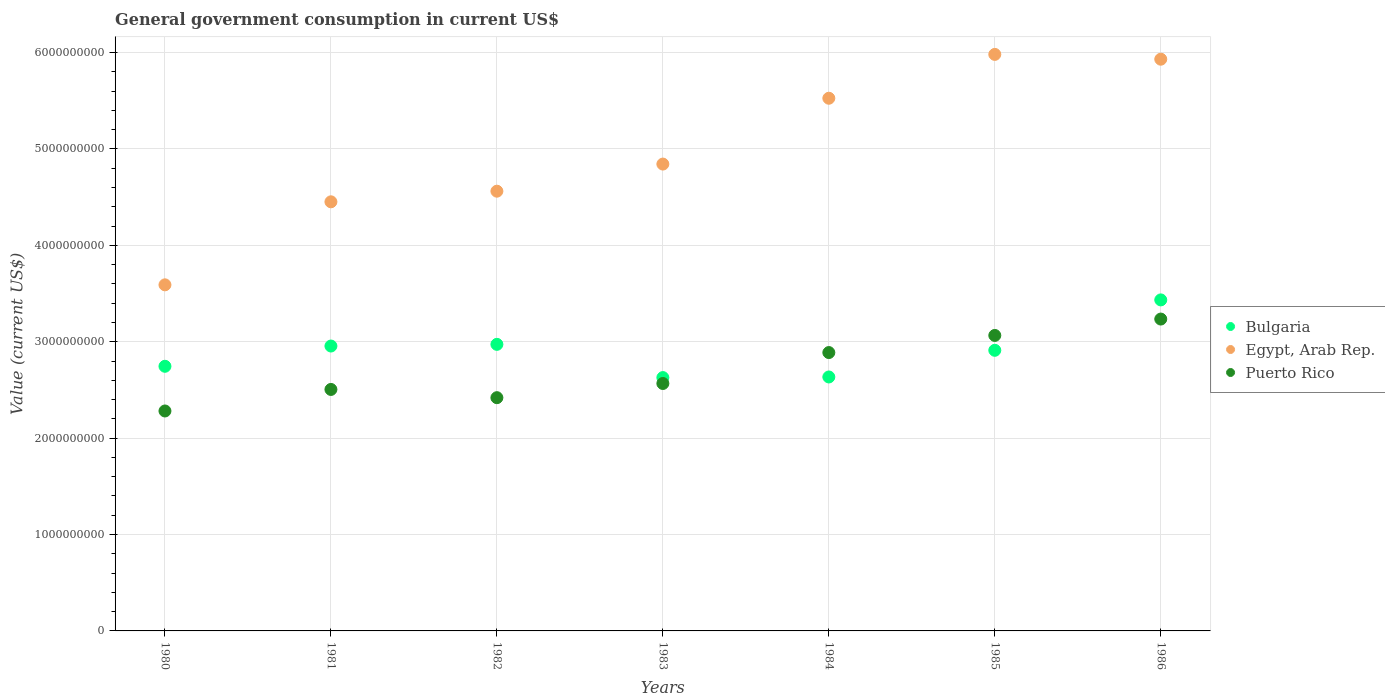How many different coloured dotlines are there?
Offer a very short reply. 3. Is the number of dotlines equal to the number of legend labels?
Your response must be concise. Yes. What is the government conusmption in Bulgaria in 1985?
Offer a terse response. 2.91e+09. Across all years, what is the maximum government conusmption in Egypt, Arab Rep.?
Keep it short and to the point. 5.98e+09. Across all years, what is the minimum government conusmption in Bulgaria?
Offer a very short reply. 2.63e+09. What is the total government conusmption in Bulgaria in the graph?
Provide a short and direct response. 2.03e+1. What is the difference between the government conusmption in Bulgaria in 1981 and that in 1983?
Give a very brief answer. 3.27e+08. What is the difference between the government conusmption in Bulgaria in 1984 and the government conusmption in Egypt, Arab Rep. in 1986?
Offer a very short reply. -3.30e+09. What is the average government conusmption in Puerto Rico per year?
Provide a short and direct response. 2.71e+09. In the year 1984, what is the difference between the government conusmption in Bulgaria and government conusmption in Puerto Rico?
Your answer should be compact. -2.53e+08. What is the ratio of the government conusmption in Bulgaria in 1981 to that in 1983?
Your response must be concise. 1.12. What is the difference between the highest and the second highest government conusmption in Puerto Rico?
Your answer should be very brief. 1.70e+08. What is the difference between the highest and the lowest government conusmption in Puerto Rico?
Offer a terse response. 9.54e+08. In how many years, is the government conusmption in Bulgaria greater than the average government conusmption in Bulgaria taken over all years?
Your answer should be compact. 4. Is the sum of the government conusmption in Bulgaria in 1980 and 1981 greater than the maximum government conusmption in Puerto Rico across all years?
Your answer should be very brief. Yes. Is it the case that in every year, the sum of the government conusmption in Bulgaria and government conusmption in Puerto Rico  is greater than the government conusmption in Egypt, Arab Rep.?
Keep it short and to the point. No. Does the government conusmption in Puerto Rico monotonically increase over the years?
Offer a terse response. No. Is the government conusmption in Bulgaria strictly greater than the government conusmption in Egypt, Arab Rep. over the years?
Provide a short and direct response. No. Is the government conusmption in Puerto Rico strictly less than the government conusmption in Egypt, Arab Rep. over the years?
Provide a succinct answer. Yes. How many dotlines are there?
Give a very brief answer. 3. What is the difference between two consecutive major ticks on the Y-axis?
Your answer should be compact. 1.00e+09. Does the graph contain any zero values?
Offer a very short reply. No. Does the graph contain grids?
Offer a very short reply. Yes. How many legend labels are there?
Ensure brevity in your answer.  3. What is the title of the graph?
Your answer should be compact. General government consumption in current US$. Does "Jordan" appear as one of the legend labels in the graph?
Keep it short and to the point. No. What is the label or title of the Y-axis?
Your answer should be compact. Value (current US$). What is the Value (current US$) of Bulgaria in 1980?
Make the answer very short. 2.75e+09. What is the Value (current US$) of Egypt, Arab Rep. in 1980?
Ensure brevity in your answer.  3.59e+09. What is the Value (current US$) in Puerto Rico in 1980?
Ensure brevity in your answer.  2.28e+09. What is the Value (current US$) of Bulgaria in 1981?
Offer a very short reply. 2.96e+09. What is the Value (current US$) in Egypt, Arab Rep. in 1981?
Offer a very short reply. 4.45e+09. What is the Value (current US$) in Puerto Rico in 1981?
Offer a very short reply. 2.50e+09. What is the Value (current US$) of Bulgaria in 1982?
Provide a short and direct response. 2.97e+09. What is the Value (current US$) in Egypt, Arab Rep. in 1982?
Ensure brevity in your answer.  4.56e+09. What is the Value (current US$) of Puerto Rico in 1982?
Keep it short and to the point. 2.42e+09. What is the Value (current US$) of Bulgaria in 1983?
Your answer should be very brief. 2.63e+09. What is the Value (current US$) in Egypt, Arab Rep. in 1983?
Make the answer very short. 4.84e+09. What is the Value (current US$) in Puerto Rico in 1983?
Offer a terse response. 2.57e+09. What is the Value (current US$) of Bulgaria in 1984?
Ensure brevity in your answer.  2.63e+09. What is the Value (current US$) of Egypt, Arab Rep. in 1984?
Keep it short and to the point. 5.53e+09. What is the Value (current US$) in Puerto Rico in 1984?
Offer a very short reply. 2.89e+09. What is the Value (current US$) in Bulgaria in 1985?
Provide a short and direct response. 2.91e+09. What is the Value (current US$) in Egypt, Arab Rep. in 1985?
Your answer should be very brief. 5.98e+09. What is the Value (current US$) of Puerto Rico in 1985?
Your response must be concise. 3.07e+09. What is the Value (current US$) of Bulgaria in 1986?
Provide a succinct answer. 3.43e+09. What is the Value (current US$) of Egypt, Arab Rep. in 1986?
Offer a terse response. 5.93e+09. What is the Value (current US$) in Puerto Rico in 1986?
Your answer should be very brief. 3.24e+09. Across all years, what is the maximum Value (current US$) of Bulgaria?
Provide a succinct answer. 3.43e+09. Across all years, what is the maximum Value (current US$) in Egypt, Arab Rep.?
Provide a short and direct response. 5.98e+09. Across all years, what is the maximum Value (current US$) of Puerto Rico?
Offer a terse response. 3.24e+09. Across all years, what is the minimum Value (current US$) of Bulgaria?
Provide a succinct answer. 2.63e+09. Across all years, what is the minimum Value (current US$) of Egypt, Arab Rep.?
Make the answer very short. 3.59e+09. Across all years, what is the minimum Value (current US$) in Puerto Rico?
Keep it short and to the point. 2.28e+09. What is the total Value (current US$) of Bulgaria in the graph?
Your answer should be very brief. 2.03e+1. What is the total Value (current US$) of Egypt, Arab Rep. in the graph?
Keep it short and to the point. 3.49e+1. What is the total Value (current US$) of Puerto Rico in the graph?
Make the answer very short. 1.90e+1. What is the difference between the Value (current US$) of Bulgaria in 1980 and that in 1981?
Offer a terse response. -2.10e+08. What is the difference between the Value (current US$) in Egypt, Arab Rep. in 1980 and that in 1981?
Offer a terse response. -8.61e+08. What is the difference between the Value (current US$) of Puerto Rico in 1980 and that in 1981?
Your response must be concise. -2.23e+08. What is the difference between the Value (current US$) in Bulgaria in 1980 and that in 1982?
Keep it short and to the point. -2.28e+08. What is the difference between the Value (current US$) in Egypt, Arab Rep. in 1980 and that in 1982?
Offer a very short reply. -9.71e+08. What is the difference between the Value (current US$) of Puerto Rico in 1980 and that in 1982?
Offer a very short reply. -1.38e+08. What is the difference between the Value (current US$) of Bulgaria in 1980 and that in 1983?
Offer a terse response. 1.17e+08. What is the difference between the Value (current US$) of Egypt, Arab Rep. in 1980 and that in 1983?
Provide a succinct answer. -1.25e+09. What is the difference between the Value (current US$) of Puerto Rico in 1980 and that in 1983?
Make the answer very short. -2.85e+08. What is the difference between the Value (current US$) in Bulgaria in 1980 and that in 1984?
Provide a succinct answer. 1.11e+08. What is the difference between the Value (current US$) of Egypt, Arab Rep. in 1980 and that in 1984?
Provide a succinct answer. -1.94e+09. What is the difference between the Value (current US$) of Puerto Rico in 1980 and that in 1984?
Keep it short and to the point. -6.06e+08. What is the difference between the Value (current US$) in Bulgaria in 1980 and that in 1985?
Give a very brief answer. -1.66e+08. What is the difference between the Value (current US$) of Egypt, Arab Rep. in 1980 and that in 1985?
Offer a very short reply. -2.39e+09. What is the difference between the Value (current US$) in Puerto Rico in 1980 and that in 1985?
Your answer should be very brief. -7.84e+08. What is the difference between the Value (current US$) of Bulgaria in 1980 and that in 1986?
Your answer should be very brief. -6.89e+08. What is the difference between the Value (current US$) of Egypt, Arab Rep. in 1980 and that in 1986?
Ensure brevity in your answer.  -2.34e+09. What is the difference between the Value (current US$) of Puerto Rico in 1980 and that in 1986?
Offer a terse response. -9.54e+08. What is the difference between the Value (current US$) of Bulgaria in 1981 and that in 1982?
Give a very brief answer. -1.74e+07. What is the difference between the Value (current US$) in Egypt, Arab Rep. in 1981 and that in 1982?
Offer a terse response. -1.10e+08. What is the difference between the Value (current US$) of Puerto Rico in 1981 and that in 1982?
Give a very brief answer. 8.54e+07. What is the difference between the Value (current US$) of Bulgaria in 1981 and that in 1983?
Offer a very short reply. 3.27e+08. What is the difference between the Value (current US$) of Egypt, Arab Rep. in 1981 and that in 1983?
Offer a very short reply. -3.91e+08. What is the difference between the Value (current US$) in Puerto Rico in 1981 and that in 1983?
Offer a very short reply. -6.17e+07. What is the difference between the Value (current US$) in Bulgaria in 1981 and that in 1984?
Provide a succinct answer. 3.21e+08. What is the difference between the Value (current US$) of Egypt, Arab Rep. in 1981 and that in 1984?
Offer a terse response. -1.07e+09. What is the difference between the Value (current US$) in Puerto Rico in 1981 and that in 1984?
Your answer should be very brief. -3.83e+08. What is the difference between the Value (current US$) of Bulgaria in 1981 and that in 1985?
Your response must be concise. 4.43e+07. What is the difference between the Value (current US$) in Egypt, Arab Rep. in 1981 and that in 1985?
Offer a terse response. -1.53e+09. What is the difference between the Value (current US$) of Puerto Rico in 1981 and that in 1985?
Provide a short and direct response. -5.60e+08. What is the difference between the Value (current US$) of Bulgaria in 1981 and that in 1986?
Your answer should be compact. -4.79e+08. What is the difference between the Value (current US$) of Egypt, Arab Rep. in 1981 and that in 1986?
Ensure brevity in your answer.  -1.48e+09. What is the difference between the Value (current US$) of Puerto Rico in 1981 and that in 1986?
Give a very brief answer. -7.30e+08. What is the difference between the Value (current US$) in Bulgaria in 1982 and that in 1983?
Provide a succinct answer. 3.45e+08. What is the difference between the Value (current US$) of Egypt, Arab Rep. in 1982 and that in 1983?
Provide a short and direct response. -2.81e+08. What is the difference between the Value (current US$) in Puerto Rico in 1982 and that in 1983?
Provide a succinct answer. -1.47e+08. What is the difference between the Value (current US$) in Bulgaria in 1982 and that in 1984?
Give a very brief answer. 3.38e+08. What is the difference between the Value (current US$) in Egypt, Arab Rep. in 1982 and that in 1984?
Your response must be concise. -9.64e+08. What is the difference between the Value (current US$) of Puerto Rico in 1982 and that in 1984?
Keep it short and to the point. -4.68e+08. What is the difference between the Value (current US$) in Bulgaria in 1982 and that in 1985?
Make the answer very short. 6.17e+07. What is the difference between the Value (current US$) in Egypt, Arab Rep. in 1982 and that in 1985?
Give a very brief answer. -1.42e+09. What is the difference between the Value (current US$) of Puerto Rico in 1982 and that in 1985?
Provide a succinct answer. -6.46e+08. What is the difference between the Value (current US$) in Bulgaria in 1982 and that in 1986?
Your response must be concise. -4.61e+08. What is the difference between the Value (current US$) in Egypt, Arab Rep. in 1982 and that in 1986?
Your answer should be very brief. -1.37e+09. What is the difference between the Value (current US$) of Puerto Rico in 1982 and that in 1986?
Make the answer very short. -8.16e+08. What is the difference between the Value (current US$) in Bulgaria in 1983 and that in 1984?
Ensure brevity in your answer.  -6.32e+06. What is the difference between the Value (current US$) in Egypt, Arab Rep. in 1983 and that in 1984?
Provide a short and direct response. -6.83e+08. What is the difference between the Value (current US$) in Puerto Rico in 1983 and that in 1984?
Offer a terse response. -3.21e+08. What is the difference between the Value (current US$) in Bulgaria in 1983 and that in 1985?
Make the answer very short. -2.83e+08. What is the difference between the Value (current US$) of Egypt, Arab Rep. in 1983 and that in 1985?
Make the answer very short. -1.14e+09. What is the difference between the Value (current US$) in Puerto Rico in 1983 and that in 1985?
Ensure brevity in your answer.  -4.98e+08. What is the difference between the Value (current US$) in Bulgaria in 1983 and that in 1986?
Ensure brevity in your answer.  -8.06e+08. What is the difference between the Value (current US$) in Egypt, Arab Rep. in 1983 and that in 1986?
Offer a very short reply. -1.09e+09. What is the difference between the Value (current US$) of Puerto Rico in 1983 and that in 1986?
Make the answer very short. -6.68e+08. What is the difference between the Value (current US$) of Bulgaria in 1984 and that in 1985?
Your answer should be very brief. -2.77e+08. What is the difference between the Value (current US$) in Egypt, Arab Rep. in 1984 and that in 1985?
Give a very brief answer. -4.55e+08. What is the difference between the Value (current US$) in Puerto Rico in 1984 and that in 1985?
Provide a succinct answer. -1.78e+08. What is the difference between the Value (current US$) in Bulgaria in 1984 and that in 1986?
Offer a terse response. -7.99e+08. What is the difference between the Value (current US$) of Egypt, Arab Rep. in 1984 and that in 1986?
Your response must be concise. -4.05e+08. What is the difference between the Value (current US$) of Puerto Rico in 1984 and that in 1986?
Make the answer very short. -3.48e+08. What is the difference between the Value (current US$) in Bulgaria in 1985 and that in 1986?
Give a very brief answer. -5.23e+08. What is the difference between the Value (current US$) in Egypt, Arab Rep. in 1985 and that in 1986?
Make the answer very short. 4.97e+07. What is the difference between the Value (current US$) of Puerto Rico in 1985 and that in 1986?
Offer a terse response. -1.70e+08. What is the difference between the Value (current US$) in Bulgaria in 1980 and the Value (current US$) in Egypt, Arab Rep. in 1981?
Ensure brevity in your answer.  -1.71e+09. What is the difference between the Value (current US$) in Bulgaria in 1980 and the Value (current US$) in Puerto Rico in 1981?
Ensure brevity in your answer.  2.40e+08. What is the difference between the Value (current US$) in Egypt, Arab Rep. in 1980 and the Value (current US$) in Puerto Rico in 1981?
Provide a succinct answer. 1.09e+09. What is the difference between the Value (current US$) in Bulgaria in 1980 and the Value (current US$) in Egypt, Arab Rep. in 1982?
Your answer should be very brief. -1.82e+09. What is the difference between the Value (current US$) in Bulgaria in 1980 and the Value (current US$) in Puerto Rico in 1982?
Keep it short and to the point. 3.26e+08. What is the difference between the Value (current US$) of Egypt, Arab Rep. in 1980 and the Value (current US$) of Puerto Rico in 1982?
Make the answer very short. 1.17e+09. What is the difference between the Value (current US$) of Bulgaria in 1980 and the Value (current US$) of Egypt, Arab Rep. in 1983?
Your response must be concise. -2.10e+09. What is the difference between the Value (current US$) of Bulgaria in 1980 and the Value (current US$) of Puerto Rico in 1983?
Make the answer very short. 1.78e+08. What is the difference between the Value (current US$) of Egypt, Arab Rep. in 1980 and the Value (current US$) of Puerto Rico in 1983?
Keep it short and to the point. 1.02e+09. What is the difference between the Value (current US$) in Bulgaria in 1980 and the Value (current US$) in Egypt, Arab Rep. in 1984?
Offer a terse response. -2.78e+09. What is the difference between the Value (current US$) of Bulgaria in 1980 and the Value (current US$) of Puerto Rico in 1984?
Your answer should be very brief. -1.42e+08. What is the difference between the Value (current US$) of Egypt, Arab Rep. in 1980 and the Value (current US$) of Puerto Rico in 1984?
Make the answer very short. 7.03e+08. What is the difference between the Value (current US$) in Bulgaria in 1980 and the Value (current US$) in Egypt, Arab Rep. in 1985?
Make the answer very short. -3.24e+09. What is the difference between the Value (current US$) in Bulgaria in 1980 and the Value (current US$) in Puerto Rico in 1985?
Offer a terse response. -3.20e+08. What is the difference between the Value (current US$) of Egypt, Arab Rep. in 1980 and the Value (current US$) of Puerto Rico in 1985?
Offer a very short reply. 5.25e+08. What is the difference between the Value (current US$) in Bulgaria in 1980 and the Value (current US$) in Egypt, Arab Rep. in 1986?
Your response must be concise. -3.19e+09. What is the difference between the Value (current US$) in Bulgaria in 1980 and the Value (current US$) in Puerto Rico in 1986?
Your answer should be very brief. -4.90e+08. What is the difference between the Value (current US$) of Egypt, Arab Rep. in 1980 and the Value (current US$) of Puerto Rico in 1986?
Provide a succinct answer. 3.55e+08. What is the difference between the Value (current US$) in Bulgaria in 1981 and the Value (current US$) in Egypt, Arab Rep. in 1982?
Give a very brief answer. -1.61e+09. What is the difference between the Value (current US$) of Bulgaria in 1981 and the Value (current US$) of Puerto Rico in 1982?
Provide a succinct answer. 5.36e+08. What is the difference between the Value (current US$) of Egypt, Arab Rep. in 1981 and the Value (current US$) of Puerto Rico in 1982?
Ensure brevity in your answer.  2.03e+09. What is the difference between the Value (current US$) of Bulgaria in 1981 and the Value (current US$) of Egypt, Arab Rep. in 1983?
Keep it short and to the point. -1.89e+09. What is the difference between the Value (current US$) of Bulgaria in 1981 and the Value (current US$) of Puerto Rico in 1983?
Offer a terse response. 3.89e+08. What is the difference between the Value (current US$) of Egypt, Arab Rep. in 1981 and the Value (current US$) of Puerto Rico in 1983?
Ensure brevity in your answer.  1.88e+09. What is the difference between the Value (current US$) in Bulgaria in 1981 and the Value (current US$) in Egypt, Arab Rep. in 1984?
Offer a terse response. -2.57e+09. What is the difference between the Value (current US$) of Bulgaria in 1981 and the Value (current US$) of Puerto Rico in 1984?
Offer a very short reply. 6.77e+07. What is the difference between the Value (current US$) in Egypt, Arab Rep. in 1981 and the Value (current US$) in Puerto Rico in 1984?
Your answer should be very brief. 1.56e+09. What is the difference between the Value (current US$) in Bulgaria in 1981 and the Value (current US$) in Egypt, Arab Rep. in 1985?
Your answer should be very brief. -3.03e+09. What is the difference between the Value (current US$) in Bulgaria in 1981 and the Value (current US$) in Puerto Rico in 1985?
Your response must be concise. -1.10e+08. What is the difference between the Value (current US$) of Egypt, Arab Rep. in 1981 and the Value (current US$) of Puerto Rico in 1985?
Offer a terse response. 1.39e+09. What is the difference between the Value (current US$) in Bulgaria in 1981 and the Value (current US$) in Egypt, Arab Rep. in 1986?
Give a very brief answer. -2.98e+09. What is the difference between the Value (current US$) of Bulgaria in 1981 and the Value (current US$) of Puerto Rico in 1986?
Your answer should be compact. -2.80e+08. What is the difference between the Value (current US$) in Egypt, Arab Rep. in 1981 and the Value (current US$) in Puerto Rico in 1986?
Your answer should be compact. 1.22e+09. What is the difference between the Value (current US$) in Bulgaria in 1982 and the Value (current US$) in Egypt, Arab Rep. in 1983?
Keep it short and to the point. -1.87e+09. What is the difference between the Value (current US$) in Bulgaria in 1982 and the Value (current US$) in Puerto Rico in 1983?
Provide a short and direct response. 4.06e+08. What is the difference between the Value (current US$) in Egypt, Arab Rep. in 1982 and the Value (current US$) in Puerto Rico in 1983?
Make the answer very short. 1.99e+09. What is the difference between the Value (current US$) of Bulgaria in 1982 and the Value (current US$) of Egypt, Arab Rep. in 1984?
Make the answer very short. -2.55e+09. What is the difference between the Value (current US$) in Bulgaria in 1982 and the Value (current US$) in Puerto Rico in 1984?
Provide a succinct answer. 8.51e+07. What is the difference between the Value (current US$) in Egypt, Arab Rep. in 1982 and the Value (current US$) in Puerto Rico in 1984?
Ensure brevity in your answer.  1.67e+09. What is the difference between the Value (current US$) in Bulgaria in 1982 and the Value (current US$) in Egypt, Arab Rep. in 1985?
Offer a very short reply. -3.01e+09. What is the difference between the Value (current US$) in Bulgaria in 1982 and the Value (current US$) in Puerto Rico in 1985?
Give a very brief answer. -9.25e+07. What is the difference between the Value (current US$) in Egypt, Arab Rep. in 1982 and the Value (current US$) in Puerto Rico in 1985?
Your answer should be compact. 1.50e+09. What is the difference between the Value (current US$) in Bulgaria in 1982 and the Value (current US$) in Egypt, Arab Rep. in 1986?
Offer a terse response. -2.96e+09. What is the difference between the Value (current US$) of Bulgaria in 1982 and the Value (current US$) of Puerto Rico in 1986?
Give a very brief answer. -2.62e+08. What is the difference between the Value (current US$) in Egypt, Arab Rep. in 1982 and the Value (current US$) in Puerto Rico in 1986?
Keep it short and to the point. 1.33e+09. What is the difference between the Value (current US$) of Bulgaria in 1983 and the Value (current US$) of Egypt, Arab Rep. in 1984?
Ensure brevity in your answer.  -2.90e+09. What is the difference between the Value (current US$) in Bulgaria in 1983 and the Value (current US$) in Puerto Rico in 1984?
Give a very brief answer. -2.60e+08. What is the difference between the Value (current US$) in Egypt, Arab Rep. in 1983 and the Value (current US$) in Puerto Rico in 1984?
Your answer should be very brief. 1.96e+09. What is the difference between the Value (current US$) in Bulgaria in 1983 and the Value (current US$) in Egypt, Arab Rep. in 1985?
Make the answer very short. -3.35e+09. What is the difference between the Value (current US$) in Bulgaria in 1983 and the Value (current US$) in Puerto Rico in 1985?
Make the answer very short. -4.37e+08. What is the difference between the Value (current US$) of Egypt, Arab Rep. in 1983 and the Value (current US$) of Puerto Rico in 1985?
Your answer should be compact. 1.78e+09. What is the difference between the Value (current US$) of Bulgaria in 1983 and the Value (current US$) of Egypt, Arab Rep. in 1986?
Give a very brief answer. -3.30e+09. What is the difference between the Value (current US$) of Bulgaria in 1983 and the Value (current US$) of Puerto Rico in 1986?
Keep it short and to the point. -6.07e+08. What is the difference between the Value (current US$) of Egypt, Arab Rep. in 1983 and the Value (current US$) of Puerto Rico in 1986?
Your answer should be compact. 1.61e+09. What is the difference between the Value (current US$) of Bulgaria in 1984 and the Value (current US$) of Egypt, Arab Rep. in 1985?
Your answer should be very brief. -3.35e+09. What is the difference between the Value (current US$) in Bulgaria in 1984 and the Value (current US$) in Puerto Rico in 1985?
Offer a very short reply. -4.31e+08. What is the difference between the Value (current US$) in Egypt, Arab Rep. in 1984 and the Value (current US$) in Puerto Rico in 1985?
Ensure brevity in your answer.  2.46e+09. What is the difference between the Value (current US$) of Bulgaria in 1984 and the Value (current US$) of Egypt, Arab Rep. in 1986?
Offer a terse response. -3.30e+09. What is the difference between the Value (current US$) in Bulgaria in 1984 and the Value (current US$) in Puerto Rico in 1986?
Keep it short and to the point. -6.01e+08. What is the difference between the Value (current US$) of Egypt, Arab Rep. in 1984 and the Value (current US$) of Puerto Rico in 1986?
Provide a short and direct response. 2.29e+09. What is the difference between the Value (current US$) of Bulgaria in 1985 and the Value (current US$) of Egypt, Arab Rep. in 1986?
Ensure brevity in your answer.  -3.02e+09. What is the difference between the Value (current US$) of Bulgaria in 1985 and the Value (current US$) of Puerto Rico in 1986?
Give a very brief answer. -3.24e+08. What is the difference between the Value (current US$) in Egypt, Arab Rep. in 1985 and the Value (current US$) in Puerto Rico in 1986?
Provide a short and direct response. 2.75e+09. What is the average Value (current US$) of Bulgaria per year?
Keep it short and to the point. 2.90e+09. What is the average Value (current US$) of Egypt, Arab Rep. per year?
Ensure brevity in your answer.  4.98e+09. What is the average Value (current US$) of Puerto Rico per year?
Your answer should be compact. 2.71e+09. In the year 1980, what is the difference between the Value (current US$) of Bulgaria and Value (current US$) of Egypt, Arab Rep.?
Your response must be concise. -8.45e+08. In the year 1980, what is the difference between the Value (current US$) of Bulgaria and Value (current US$) of Puerto Rico?
Your answer should be compact. 4.64e+08. In the year 1980, what is the difference between the Value (current US$) in Egypt, Arab Rep. and Value (current US$) in Puerto Rico?
Offer a very short reply. 1.31e+09. In the year 1981, what is the difference between the Value (current US$) in Bulgaria and Value (current US$) in Egypt, Arab Rep.?
Offer a very short reply. -1.50e+09. In the year 1981, what is the difference between the Value (current US$) in Bulgaria and Value (current US$) in Puerto Rico?
Offer a terse response. 4.50e+08. In the year 1981, what is the difference between the Value (current US$) of Egypt, Arab Rep. and Value (current US$) of Puerto Rico?
Offer a terse response. 1.95e+09. In the year 1982, what is the difference between the Value (current US$) in Bulgaria and Value (current US$) in Egypt, Arab Rep.?
Provide a short and direct response. -1.59e+09. In the year 1982, what is the difference between the Value (current US$) in Bulgaria and Value (current US$) in Puerto Rico?
Ensure brevity in your answer.  5.53e+08. In the year 1982, what is the difference between the Value (current US$) of Egypt, Arab Rep. and Value (current US$) of Puerto Rico?
Your answer should be compact. 2.14e+09. In the year 1983, what is the difference between the Value (current US$) of Bulgaria and Value (current US$) of Egypt, Arab Rep.?
Ensure brevity in your answer.  -2.21e+09. In the year 1983, what is the difference between the Value (current US$) in Bulgaria and Value (current US$) in Puerto Rico?
Provide a succinct answer. 6.13e+07. In the year 1983, what is the difference between the Value (current US$) of Egypt, Arab Rep. and Value (current US$) of Puerto Rico?
Offer a very short reply. 2.28e+09. In the year 1984, what is the difference between the Value (current US$) in Bulgaria and Value (current US$) in Egypt, Arab Rep.?
Provide a succinct answer. -2.89e+09. In the year 1984, what is the difference between the Value (current US$) of Bulgaria and Value (current US$) of Puerto Rico?
Make the answer very short. -2.53e+08. In the year 1984, what is the difference between the Value (current US$) in Egypt, Arab Rep. and Value (current US$) in Puerto Rico?
Give a very brief answer. 2.64e+09. In the year 1985, what is the difference between the Value (current US$) in Bulgaria and Value (current US$) in Egypt, Arab Rep.?
Make the answer very short. -3.07e+09. In the year 1985, what is the difference between the Value (current US$) of Bulgaria and Value (current US$) of Puerto Rico?
Keep it short and to the point. -1.54e+08. In the year 1985, what is the difference between the Value (current US$) of Egypt, Arab Rep. and Value (current US$) of Puerto Rico?
Keep it short and to the point. 2.92e+09. In the year 1986, what is the difference between the Value (current US$) in Bulgaria and Value (current US$) in Egypt, Arab Rep.?
Keep it short and to the point. -2.50e+09. In the year 1986, what is the difference between the Value (current US$) of Bulgaria and Value (current US$) of Puerto Rico?
Make the answer very short. 1.99e+08. In the year 1986, what is the difference between the Value (current US$) of Egypt, Arab Rep. and Value (current US$) of Puerto Rico?
Your response must be concise. 2.70e+09. What is the ratio of the Value (current US$) in Bulgaria in 1980 to that in 1981?
Provide a short and direct response. 0.93. What is the ratio of the Value (current US$) in Egypt, Arab Rep. in 1980 to that in 1981?
Provide a short and direct response. 0.81. What is the ratio of the Value (current US$) of Puerto Rico in 1980 to that in 1981?
Your answer should be compact. 0.91. What is the ratio of the Value (current US$) of Bulgaria in 1980 to that in 1982?
Make the answer very short. 0.92. What is the ratio of the Value (current US$) of Egypt, Arab Rep. in 1980 to that in 1982?
Keep it short and to the point. 0.79. What is the ratio of the Value (current US$) in Puerto Rico in 1980 to that in 1982?
Offer a terse response. 0.94. What is the ratio of the Value (current US$) of Bulgaria in 1980 to that in 1983?
Give a very brief answer. 1.04. What is the ratio of the Value (current US$) in Egypt, Arab Rep. in 1980 to that in 1983?
Your response must be concise. 0.74. What is the ratio of the Value (current US$) in Puerto Rico in 1980 to that in 1983?
Ensure brevity in your answer.  0.89. What is the ratio of the Value (current US$) in Bulgaria in 1980 to that in 1984?
Keep it short and to the point. 1.04. What is the ratio of the Value (current US$) of Egypt, Arab Rep. in 1980 to that in 1984?
Provide a succinct answer. 0.65. What is the ratio of the Value (current US$) of Puerto Rico in 1980 to that in 1984?
Give a very brief answer. 0.79. What is the ratio of the Value (current US$) in Bulgaria in 1980 to that in 1985?
Provide a short and direct response. 0.94. What is the ratio of the Value (current US$) of Egypt, Arab Rep. in 1980 to that in 1985?
Keep it short and to the point. 0.6. What is the ratio of the Value (current US$) in Puerto Rico in 1980 to that in 1985?
Your answer should be compact. 0.74. What is the ratio of the Value (current US$) of Bulgaria in 1980 to that in 1986?
Provide a succinct answer. 0.8. What is the ratio of the Value (current US$) of Egypt, Arab Rep. in 1980 to that in 1986?
Give a very brief answer. 0.61. What is the ratio of the Value (current US$) of Puerto Rico in 1980 to that in 1986?
Your answer should be very brief. 0.71. What is the ratio of the Value (current US$) in Bulgaria in 1981 to that in 1982?
Your response must be concise. 0.99. What is the ratio of the Value (current US$) in Egypt, Arab Rep. in 1981 to that in 1982?
Provide a succinct answer. 0.98. What is the ratio of the Value (current US$) in Puerto Rico in 1981 to that in 1982?
Give a very brief answer. 1.04. What is the ratio of the Value (current US$) in Bulgaria in 1981 to that in 1983?
Your answer should be compact. 1.12. What is the ratio of the Value (current US$) in Egypt, Arab Rep. in 1981 to that in 1983?
Provide a short and direct response. 0.92. What is the ratio of the Value (current US$) in Bulgaria in 1981 to that in 1984?
Your answer should be compact. 1.12. What is the ratio of the Value (current US$) of Egypt, Arab Rep. in 1981 to that in 1984?
Keep it short and to the point. 0.81. What is the ratio of the Value (current US$) of Puerto Rico in 1981 to that in 1984?
Keep it short and to the point. 0.87. What is the ratio of the Value (current US$) in Bulgaria in 1981 to that in 1985?
Give a very brief answer. 1.02. What is the ratio of the Value (current US$) of Egypt, Arab Rep. in 1981 to that in 1985?
Make the answer very short. 0.74. What is the ratio of the Value (current US$) of Puerto Rico in 1981 to that in 1985?
Keep it short and to the point. 0.82. What is the ratio of the Value (current US$) of Bulgaria in 1981 to that in 1986?
Provide a short and direct response. 0.86. What is the ratio of the Value (current US$) of Egypt, Arab Rep. in 1981 to that in 1986?
Offer a very short reply. 0.75. What is the ratio of the Value (current US$) in Puerto Rico in 1981 to that in 1986?
Ensure brevity in your answer.  0.77. What is the ratio of the Value (current US$) of Bulgaria in 1982 to that in 1983?
Give a very brief answer. 1.13. What is the ratio of the Value (current US$) of Egypt, Arab Rep. in 1982 to that in 1983?
Your answer should be compact. 0.94. What is the ratio of the Value (current US$) of Puerto Rico in 1982 to that in 1983?
Provide a succinct answer. 0.94. What is the ratio of the Value (current US$) in Bulgaria in 1982 to that in 1984?
Your answer should be compact. 1.13. What is the ratio of the Value (current US$) of Egypt, Arab Rep. in 1982 to that in 1984?
Provide a short and direct response. 0.83. What is the ratio of the Value (current US$) of Puerto Rico in 1982 to that in 1984?
Give a very brief answer. 0.84. What is the ratio of the Value (current US$) in Bulgaria in 1982 to that in 1985?
Provide a short and direct response. 1.02. What is the ratio of the Value (current US$) in Egypt, Arab Rep. in 1982 to that in 1985?
Give a very brief answer. 0.76. What is the ratio of the Value (current US$) of Puerto Rico in 1982 to that in 1985?
Your answer should be very brief. 0.79. What is the ratio of the Value (current US$) in Bulgaria in 1982 to that in 1986?
Offer a terse response. 0.87. What is the ratio of the Value (current US$) in Egypt, Arab Rep. in 1982 to that in 1986?
Make the answer very short. 0.77. What is the ratio of the Value (current US$) of Puerto Rico in 1982 to that in 1986?
Your response must be concise. 0.75. What is the ratio of the Value (current US$) in Bulgaria in 1983 to that in 1984?
Provide a succinct answer. 1. What is the ratio of the Value (current US$) in Egypt, Arab Rep. in 1983 to that in 1984?
Offer a very short reply. 0.88. What is the ratio of the Value (current US$) of Puerto Rico in 1983 to that in 1984?
Your response must be concise. 0.89. What is the ratio of the Value (current US$) in Bulgaria in 1983 to that in 1985?
Your answer should be compact. 0.9. What is the ratio of the Value (current US$) in Egypt, Arab Rep. in 1983 to that in 1985?
Give a very brief answer. 0.81. What is the ratio of the Value (current US$) of Puerto Rico in 1983 to that in 1985?
Your answer should be very brief. 0.84. What is the ratio of the Value (current US$) of Bulgaria in 1983 to that in 1986?
Your response must be concise. 0.77. What is the ratio of the Value (current US$) in Egypt, Arab Rep. in 1983 to that in 1986?
Give a very brief answer. 0.82. What is the ratio of the Value (current US$) of Puerto Rico in 1983 to that in 1986?
Offer a terse response. 0.79. What is the ratio of the Value (current US$) of Bulgaria in 1984 to that in 1985?
Provide a short and direct response. 0.91. What is the ratio of the Value (current US$) of Egypt, Arab Rep. in 1984 to that in 1985?
Provide a short and direct response. 0.92. What is the ratio of the Value (current US$) in Puerto Rico in 1984 to that in 1985?
Ensure brevity in your answer.  0.94. What is the ratio of the Value (current US$) in Bulgaria in 1984 to that in 1986?
Keep it short and to the point. 0.77. What is the ratio of the Value (current US$) in Egypt, Arab Rep. in 1984 to that in 1986?
Keep it short and to the point. 0.93. What is the ratio of the Value (current US$) of Puerto Rico in 1984 to that in 1986?
Provide a short and direct response. 0.89. What is the ratio of the Value (current US$) of Bulgaria in 1985 to that in 1986?
Your answer should be very brief. 0.85. What is the ratio of the Value (current US$) of Egypt, Arab Rep. in 1985 to that in 1986?
Your answer should be very brief. 1.01. What is the ratio of the Value (current US$) in Puerto Rico in 1985 to that in 1986?
Make the answer very short. 0.95. What is the difference between the highest and the second highest Value (current US$) in Bulgaria?
Make the answer very short. 4.61e+08. What is the difference between the highest and the second highest Value (current US$) of Egypt, Arab Rep.?
Provide a short and direct response. 4.97e+07. What is the difference between the highest and the second highest Value (current US$) of Puerto Rico?
Offer a very short reply. 1.70e+08. What is the difference between the highest and the lowest Value (current US$) of Bulgaria?
Make the answer very short. 8.06e+08. What is the difference between the highest and the lowest Value (current US$) of Egypt, Arab Rep.?
Give a very brief answer. 2.39e+09. What is the difference between the highest and the lowest Value (current US$) of Puerto Rico?
Give a very brief answer. 9.54e+08. 